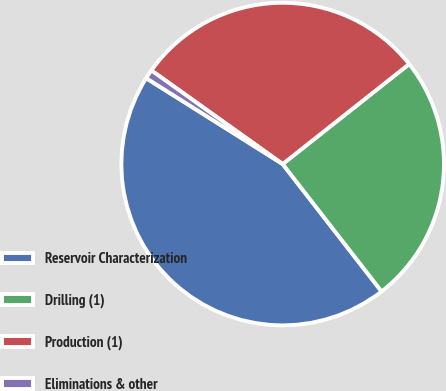<chart> <loc_0><loc_0><loc_500><loc_500><pie_chart><fcel>Reservoir Characterization<fcel>Drilling (1)<fcel>Production (1)<fcel>Eliminations & other<nl><fcel>44.44%<fcel>25.14%<fcel>29.49%<fcel>0.92%<nl></chart> 